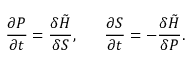<formula> <loc_0><loc_0><loc_500><loc_500>\frac { \partial P } { \partial t } = \frac { \delta \tilde { H } } { \delta S } , \frac { \partial S } { \partial t } = - \frac { \delta \tilde { H } } { \delta P } .</formula> 